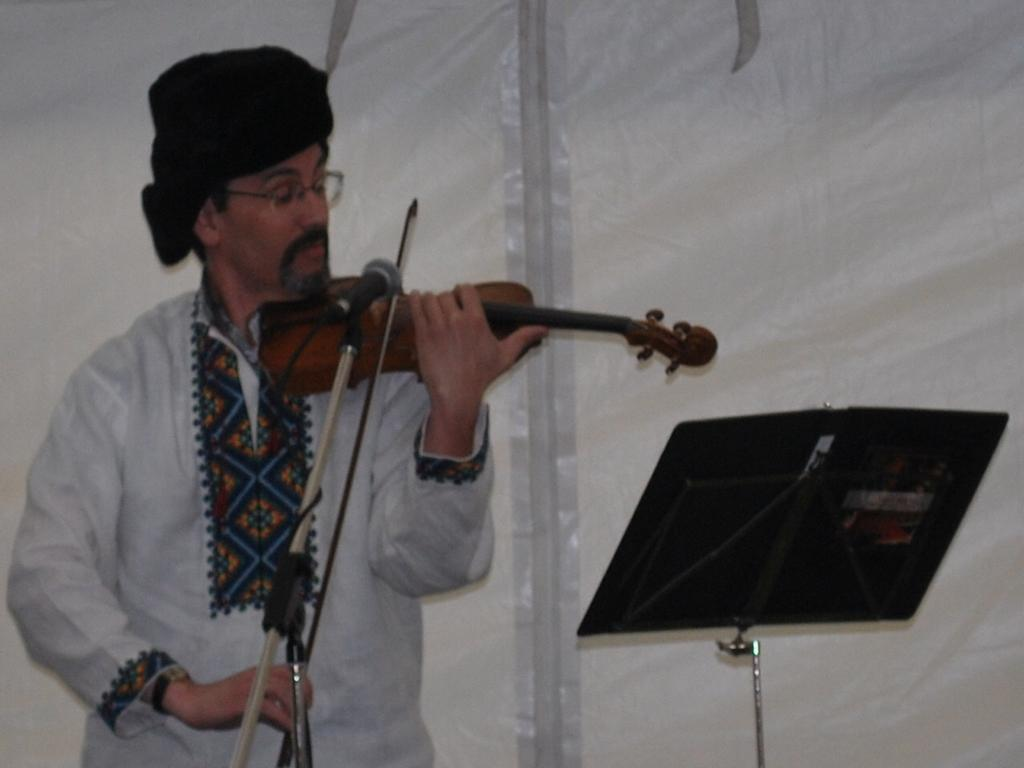What is the man in the image doing? The man is playing a violin in the image. What is the man using to amplify his sound? There is a microphone in front of the man. What is the man standing in front of? There is a stand in front of the man. What type of haircut does the minister have in the image? There is no minister present in the image, and therefore no haircut to describe. 